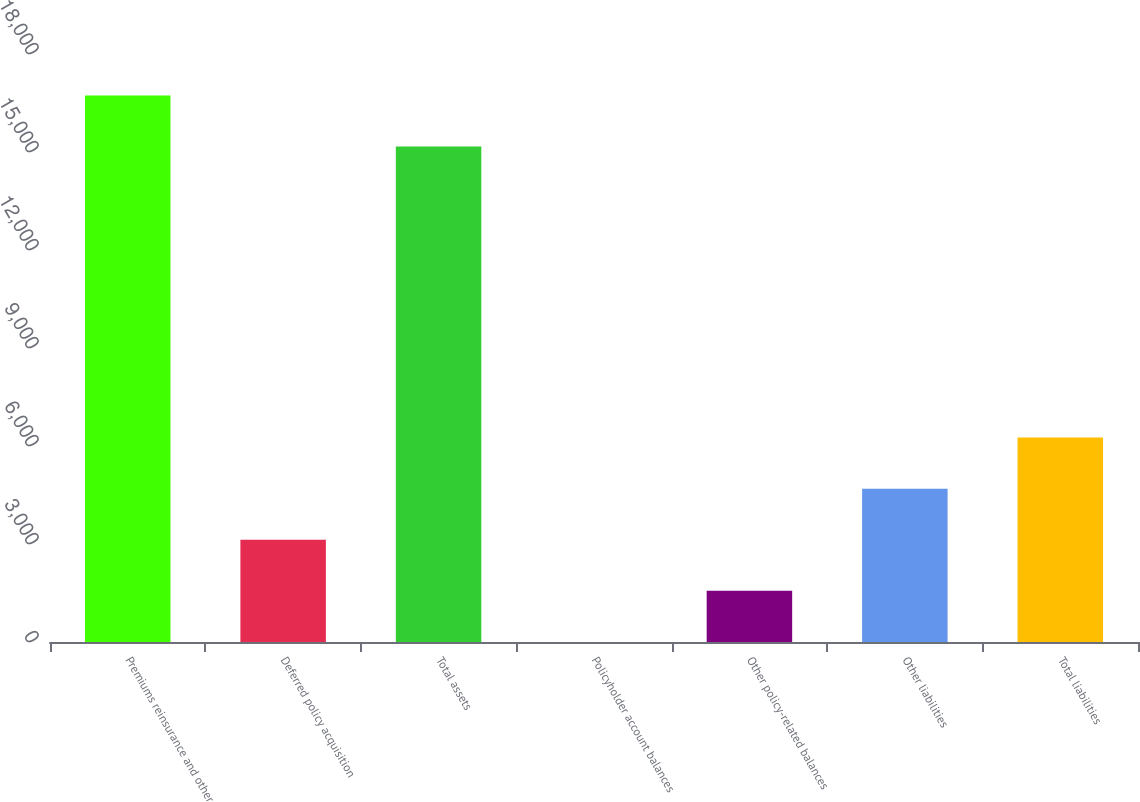<chart> <loc_0><loc_0><loc_500><loc_500><bar_chart><fcel>Premiums reinsurance and other<fcel>Deferred policy acquisition<fcel>Total assets<fcel>Policyholder account balances<fcel>Other policy-related balances<fcel>Other liabilities<fcel>Total liabilities<nl><fcel>16729<fcel>3130<fcel>15165<fcel>2<fcel>1566<fcel>4694<fcel>6258<nl></chart> 